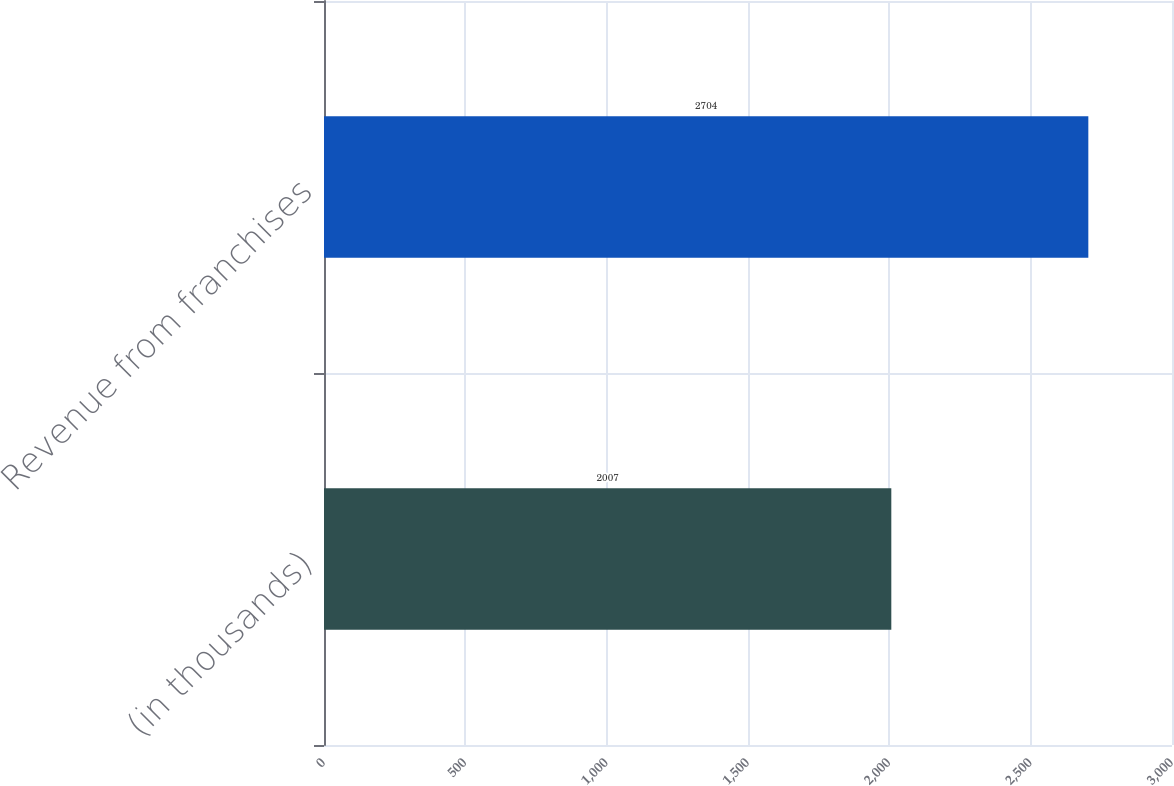Convert chart to OTSL. <chart><loc_0><loc_0><loc_500><loc_500><bar_chart><fcel>(in thousands)<fcel>Revenue from franchises<nl><fcel>2007<fcel>2704<nl></chart> 